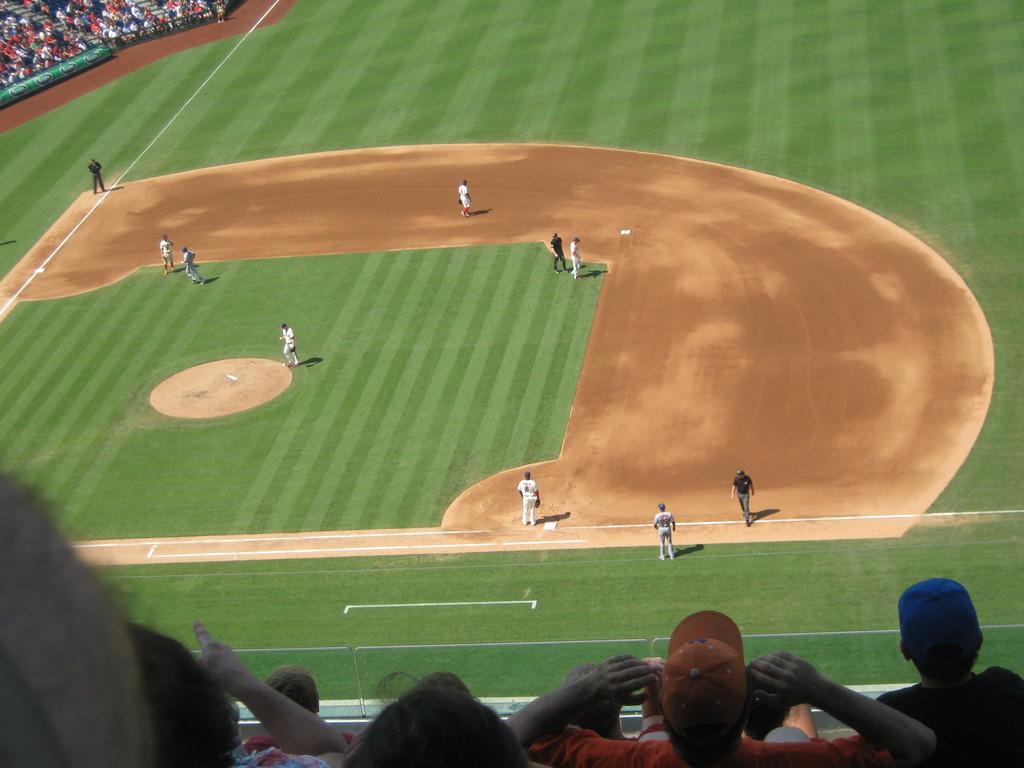Could you give a brief overview of what you see in this image? In this picture we can see baseball pitch. On the bottom there is a bowler who is wearing white dress. On the right there are two persons standing on the lang and on the left we can see umpire and wicket keeper. On the top left corner we can see audience was sitting on the stadium. On the bottom we can see group of persons watching the game. 